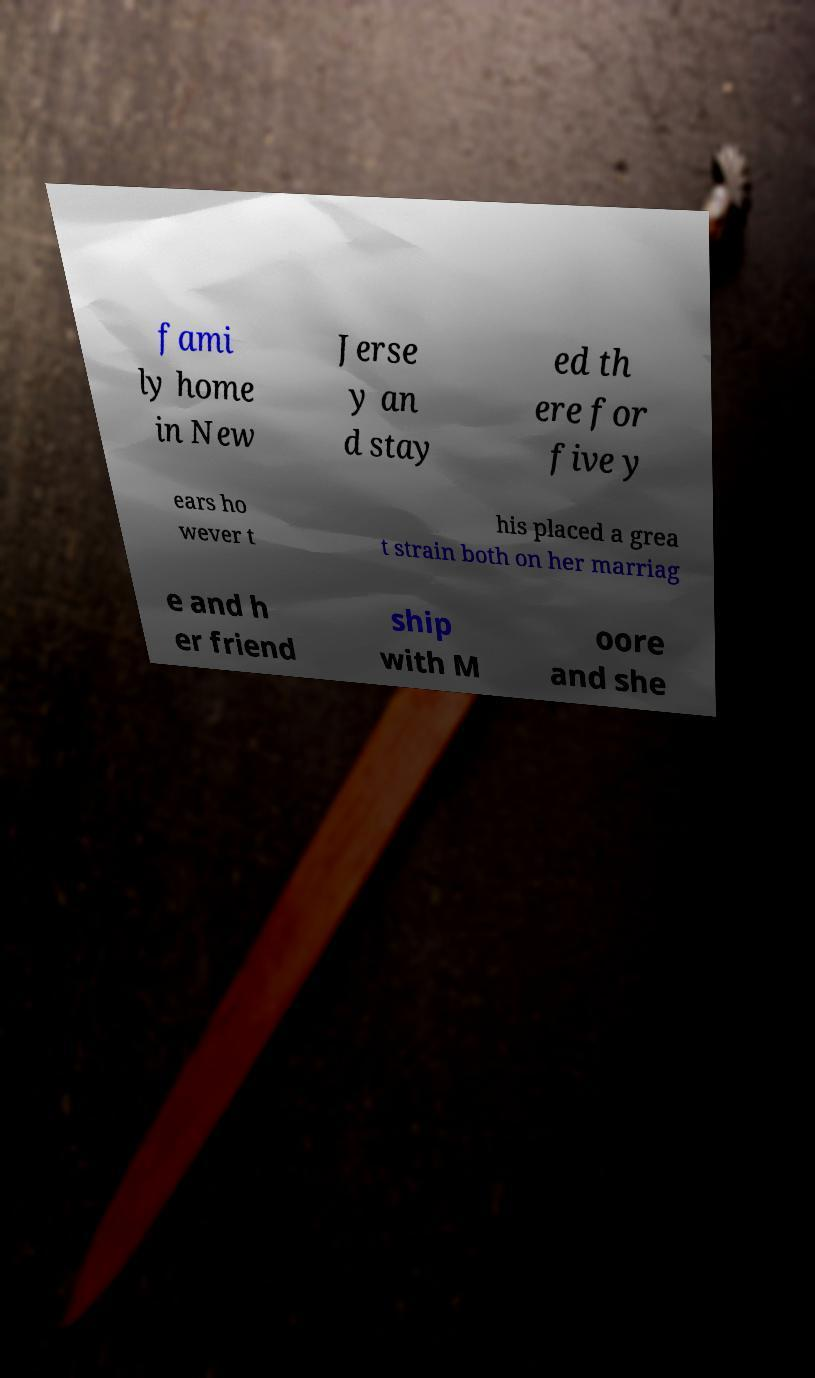Could you extract and type out the text from this image? fami ly home in New Jerse y an d stay ed th ere for five y ears ho wever t his placed a grea t strain both on her marriag e and h er friend ship with M oore and she 